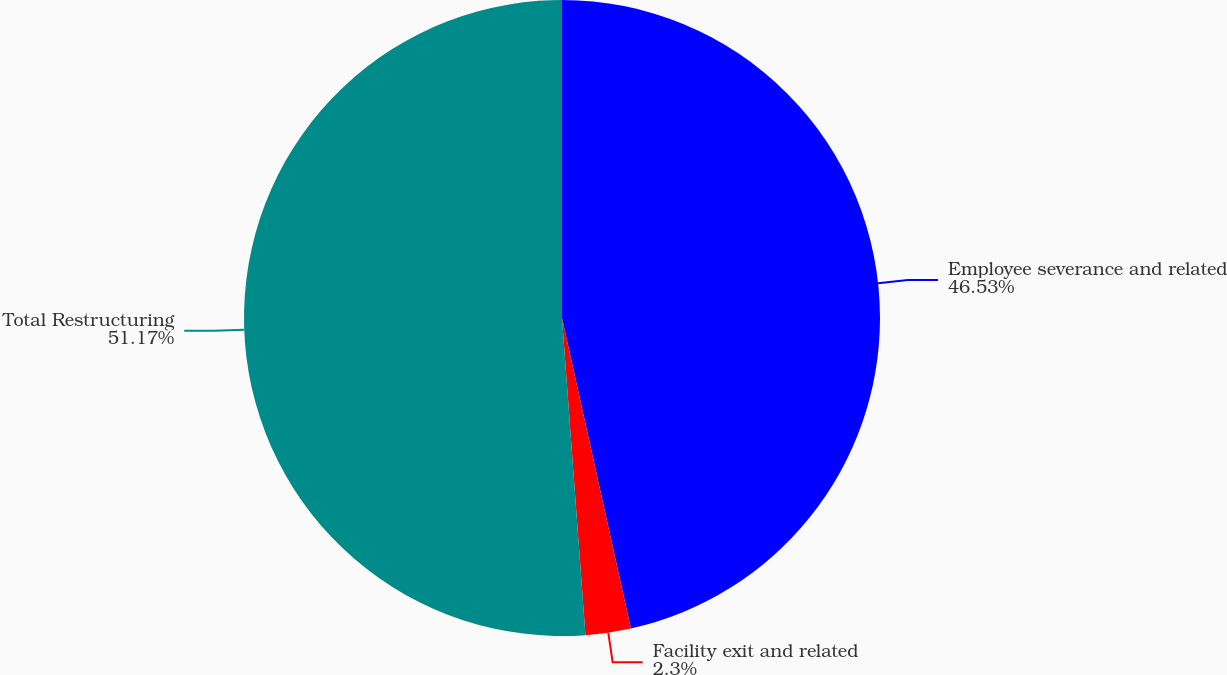Convert chart to OTSL. <chart><loc_0><loc_0><loc_500><loc_500><pie_chart><fcel>Employee severance and related<fcel>Facility exit and related<fcel>Total Restructuring<nl><fcel>46.53%<fcel>2.3%<fcel>51.18%<nl></chart> 